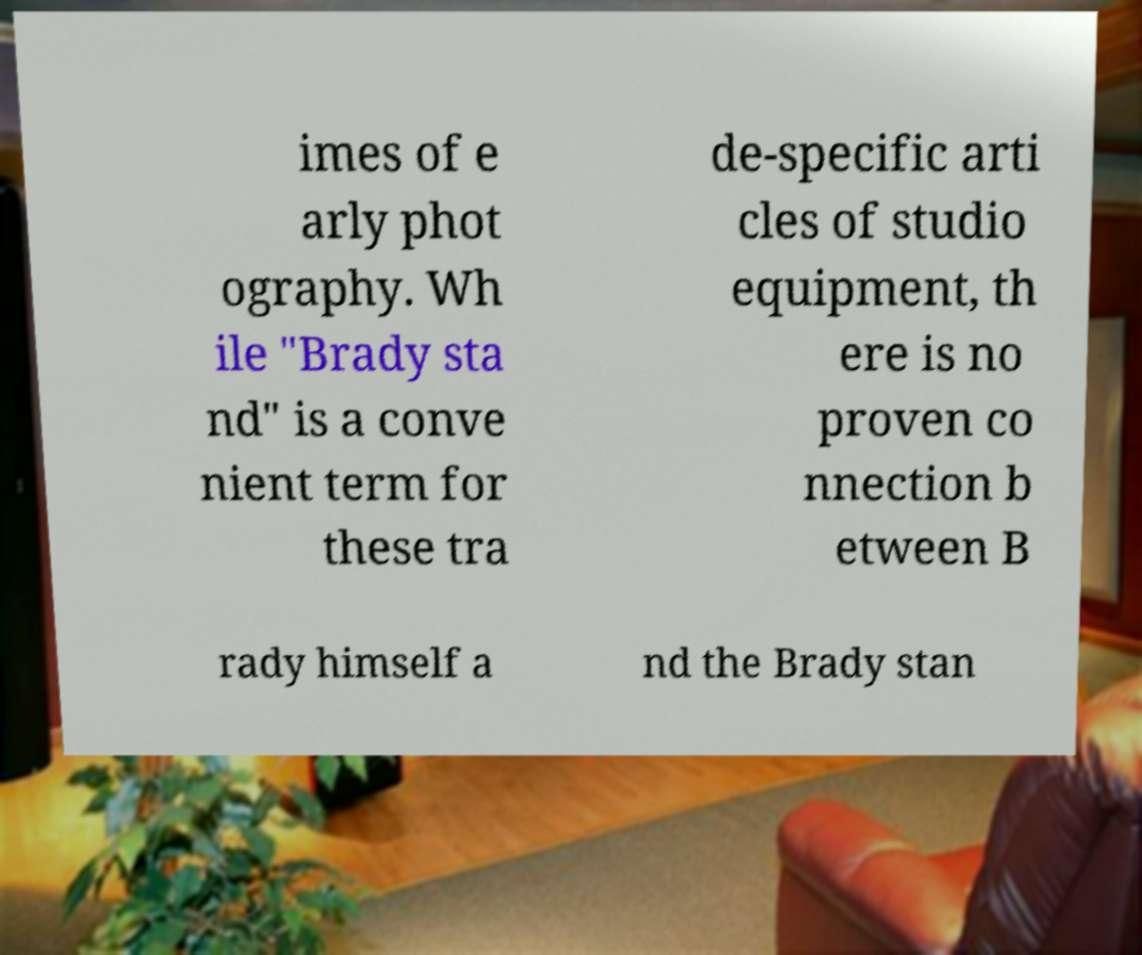There's text embedded in this image that I need extracted. Can you transcribe it verbatim? imes of e arly phot ography. Wh ile "Brady sta nd" is a conve nient term for these tra de-specific arti cles of studio equipment, th ere is no proven co nnection b etween B rady himself a nd the Brady stan 